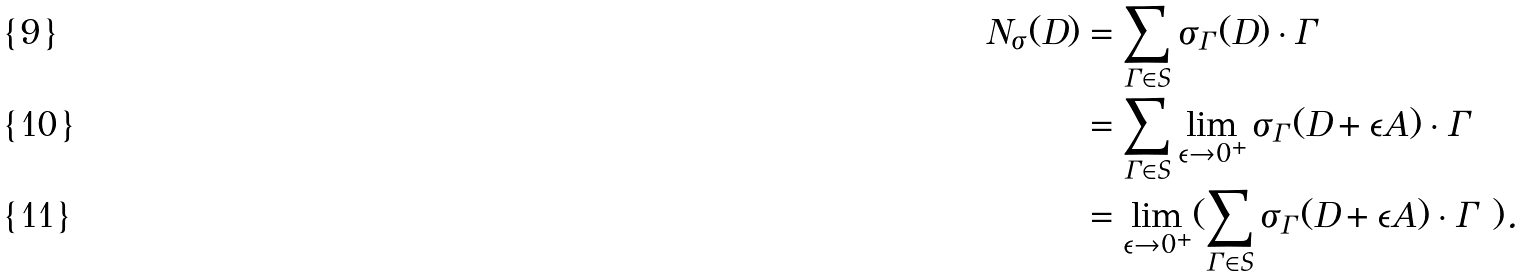<formula> <loc_0><loc_0><loc_500><loc_500>N _ { \sigma } ( D ) & = \sum _ { \Gamma \in S } \sigma _ { \Gamma } ( D ) \cdot \Gamma \\ & = \sum _ { \Gamma \in S } \lim _ { \epsilon \to 0 ^ { + } } \sigma _ { \Gamma } ( D + \epsilon A ) \cdot \Gamma \\ & = \lim _ { \epsilon \to 0 ^ { + } } ( \sum _ { \Gamma \in S } \sigma _ { \Gamma } ( D + \epsilon A ) \cdot \Gamma \ ) .</formula> 